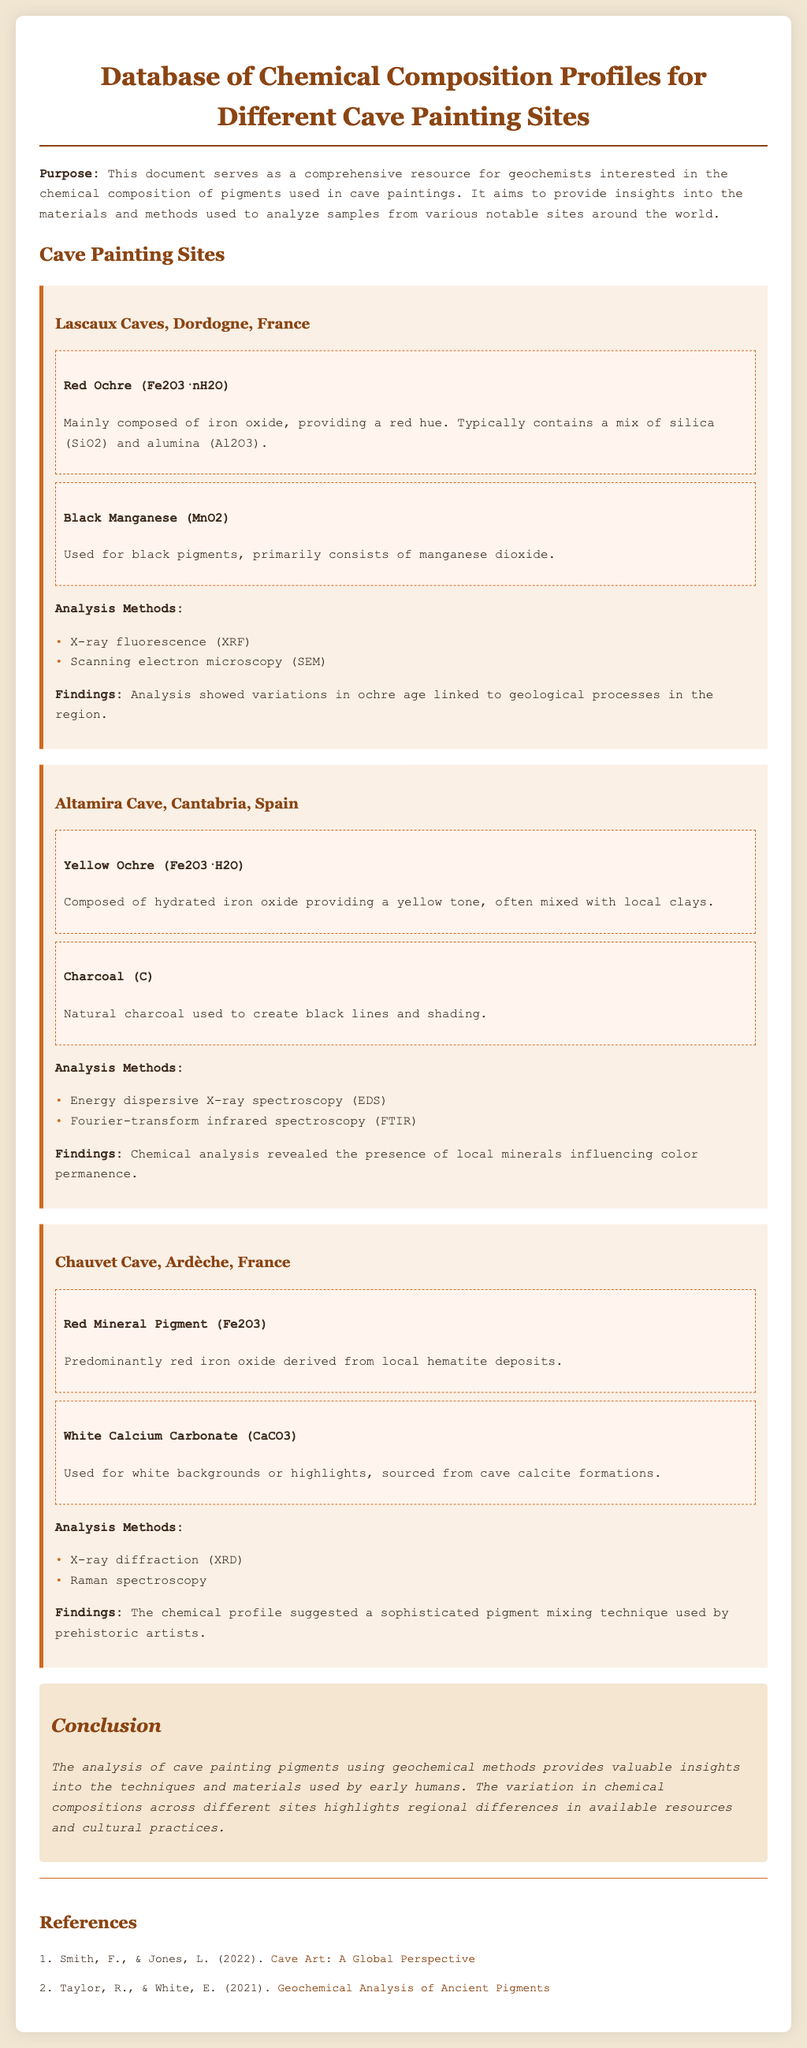What pigments are used in Lascaux Caves? The document lists Red Ochre and Black Manganese as the pigments used in the Lascaux Caves.
Answer: Red Ochre, Black Manganese What analysis methods are employed at Altamira Cave? The analysis methods for Altamira Cave include Energy dispersive X-ray spectroscopy and Fourier-transform infrared spectroscopy.
Answer: Energy dispersive X-ray spectroscopy, Fourier-transform infrared spectroscopy Which cave features white calcium carbonate? The Chauvet Cave is noted for using White Calcium Carbonate as a pigment.
Answer: Chauvet Cave What conclusions can be drawn about pigment composition? The conclusion states that the analysis of cave painting pigments shows variations in chemical compositions highlighting regional differences.
Answer: Variations in chemical compositions How many references are listed in the document? The document includes a total of two references.
Answer: 2 